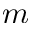Convert formula to latex. <formula><loc_0><loc_0><loc_500><loc_500>m</formula> 